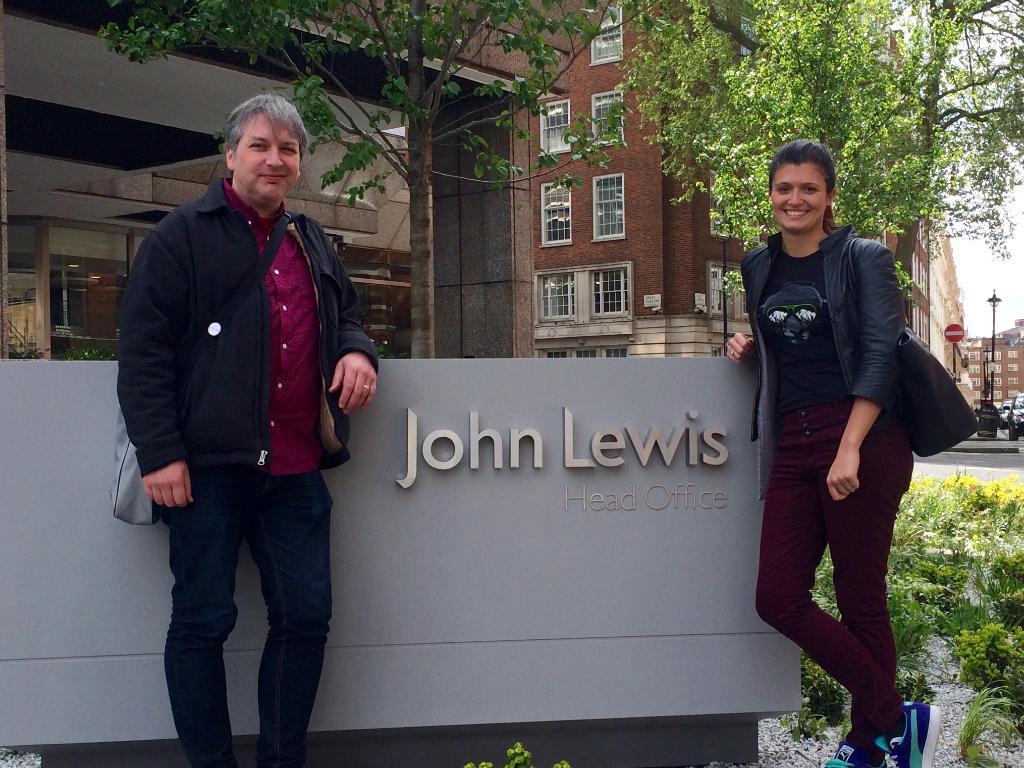How would you summarize this image in a sentence or two? In this image there are two persons standing on either side of the wall. On the wall there is some text. In the background there is a tall building with the windows. On the ground there are small plants. In the background there are small plants. On the right side there is a woman and on the left side there is a man. 